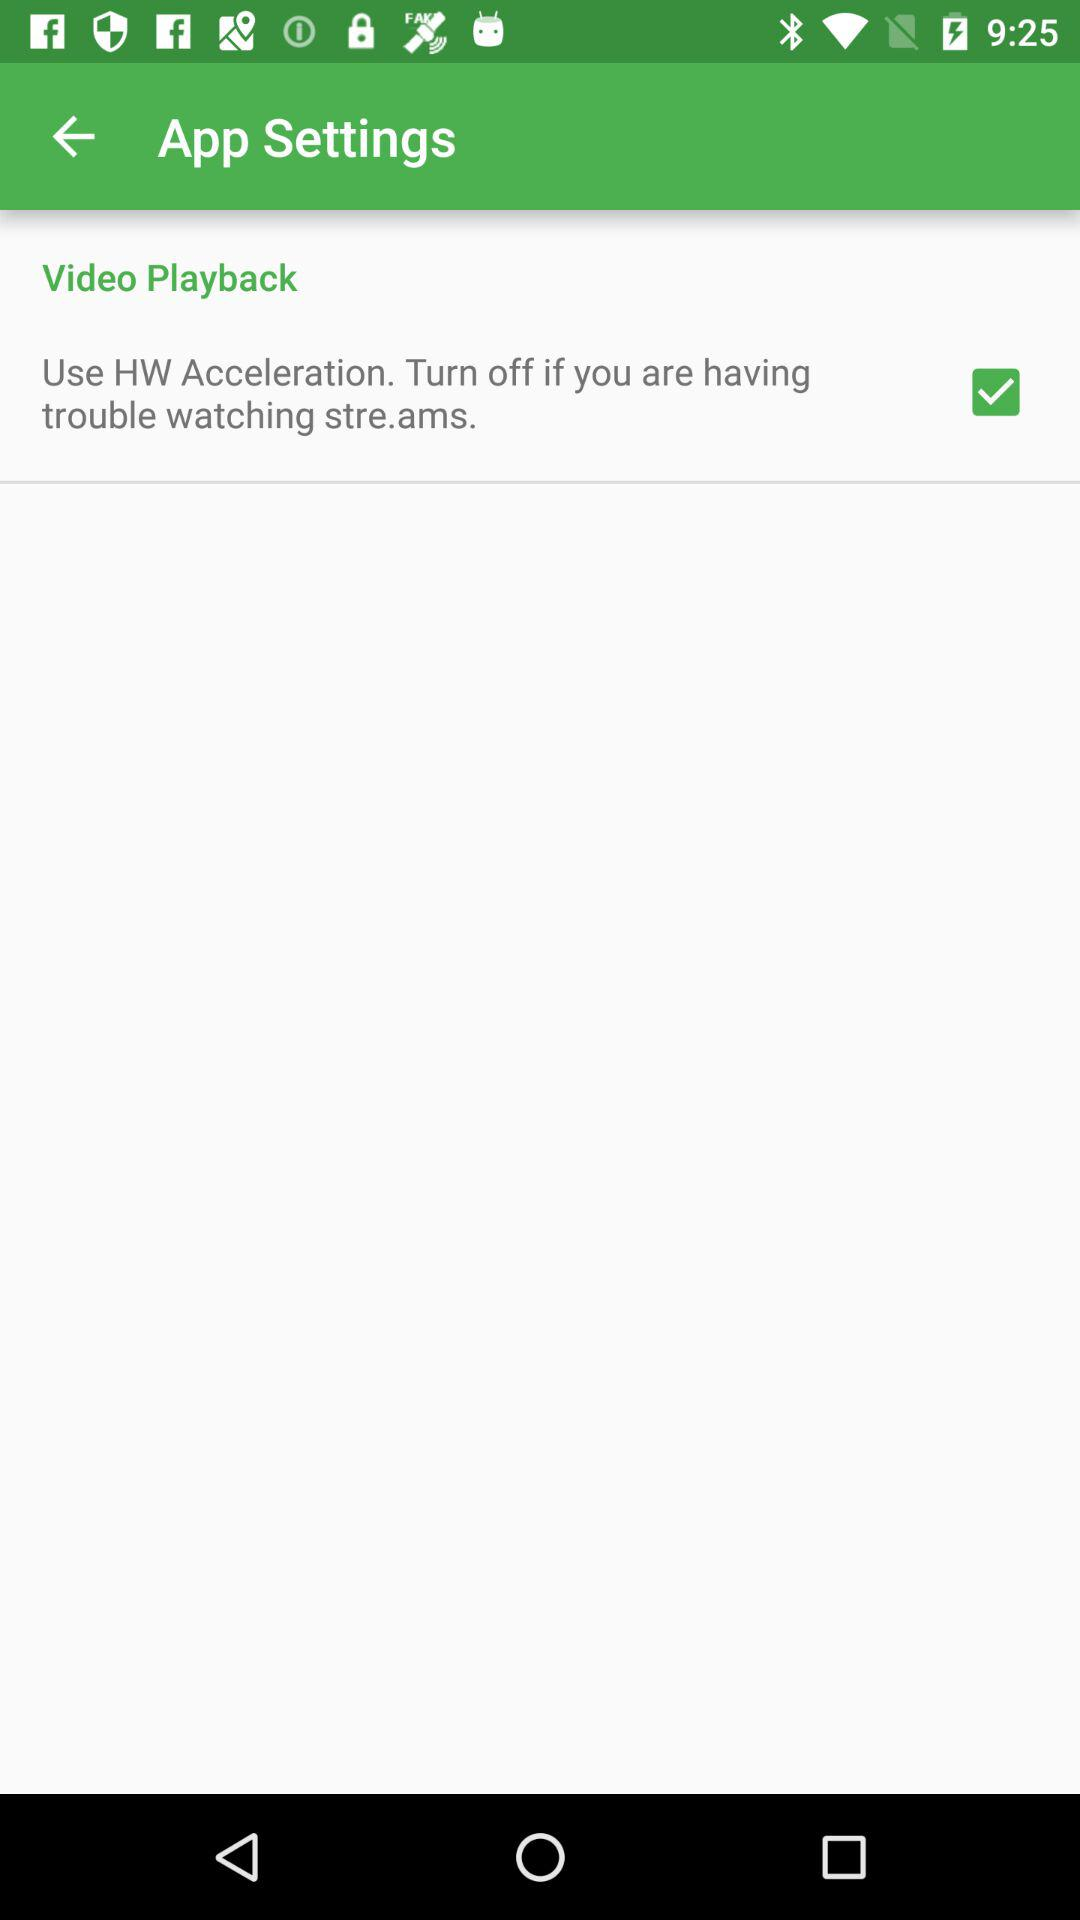What are the settings of the audio playback?
When the provided information is insufficient, respond with <no answer>. <no answer> 